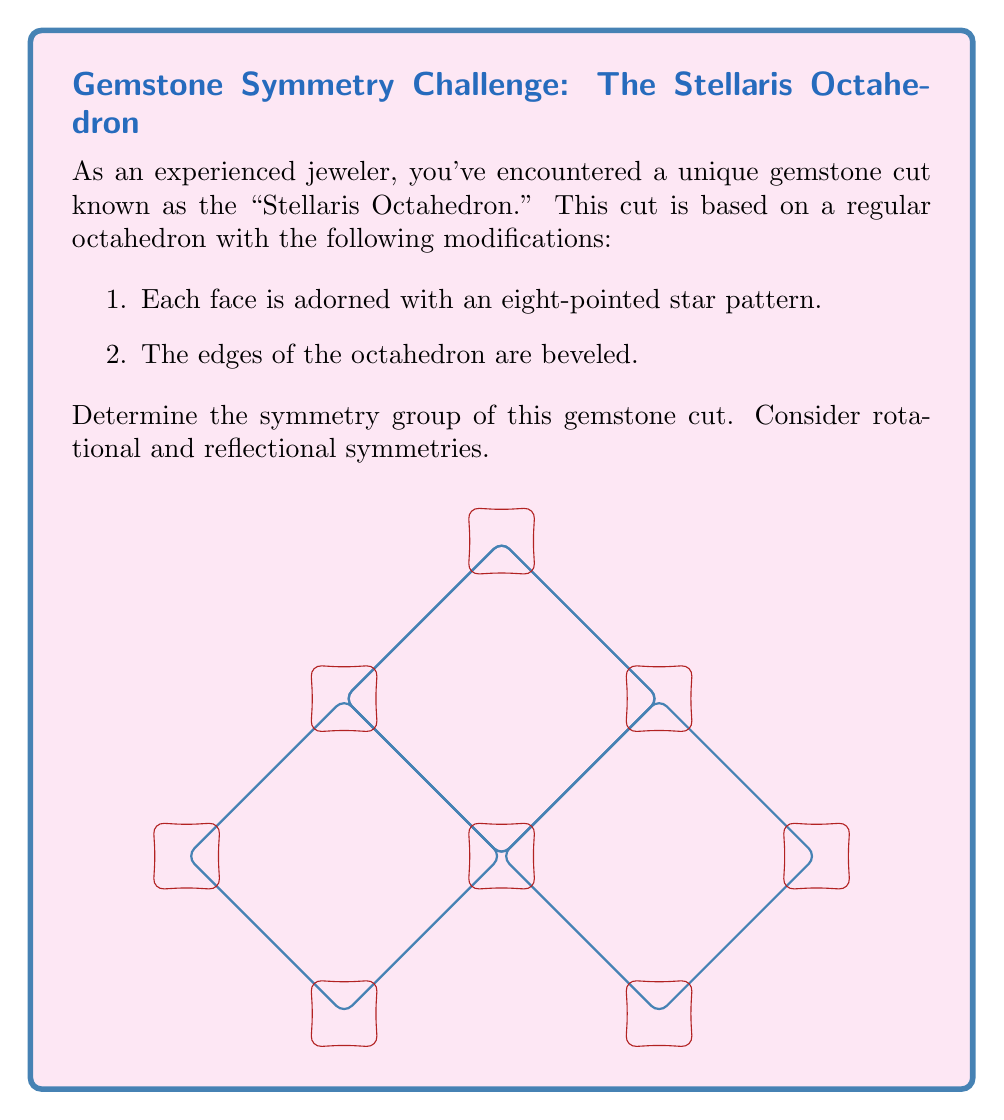Can you answer this question? To determine the symmetry group of the Stellaris Octahedron, let's analyze its symmetries step-by-step:

1. Rotational Symmetries:
   a) The octahedron has 3-fold rotational symmetry through each of its 6 vertices.
   b) It has 4-fold rotational symmetry through the center of each of its 8 faces.
   c) It has 2-fold rotational symmetry through the midpoint of each of its 12 edges.

2. Reflectional Symmetries:
   The octahedron has 9 planes of symmetry:
   a) 3 planes passing through opposite edges
   b) 6 planes passing through opposite vertices

3. The star patterns on each face and the beveled edges do not change these symmetries, as they are applied consistently to all faces and edges.

4. The symmetry group of a regular octahedron is known as the Oh group in Schönflies notation, or m-3m in Hermann–Mauguin notation.

5. This group has order 48, which can be calculated as follows:
   - 24 rotations (including the identity)
   - 24 rotations followed by inversion (which includes the 9 reflections)

6. The group structure is isomorphic to $S_4 \times C_2$, where $S_4$ is the symmetric group on 4 elements and $C_2$ is the cyclic group of order 2.

Therefore, despite the decorative star patterns and beveled edges, the Stellaris Octahedron retains the full symmetry group of a regular octahedron.
Answer: $O_h$ (Schönflies) or m-3m (Hermann–Mauguin) 